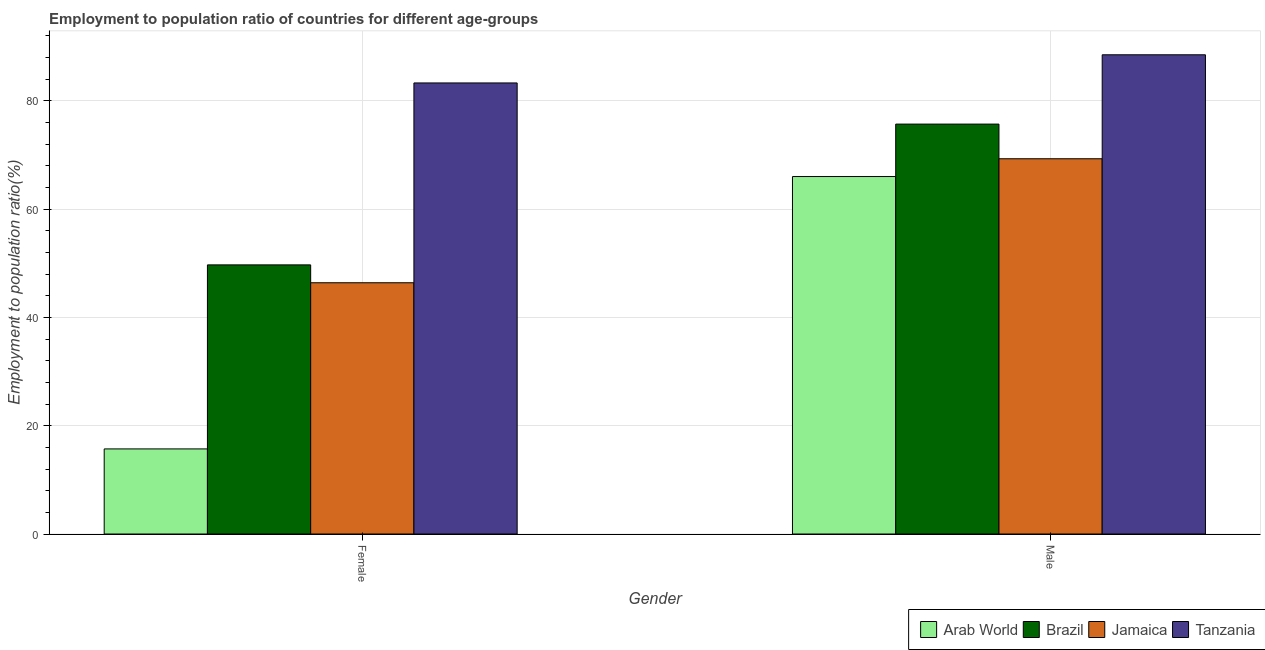How many different coloured bars are there?
Provide a short and direct response. 4. How many groups of bars are there?
Provide a short and direct response. 2. Are the number of bars on each tick of the X-axis equal?
Provide a succinct answer. Yes. What is the employment to population ratio(female) in Arab World?
Give a very brief answer. 15.71. Across all countries, what is the maximum employment to population ratio(female)?
Your answer should be compact. 83.3. Across all countries, what is the minimum employment to population ratio(female)?
Keep it short and to the point. 15.71. In which country was the employment to population ratio(male) maximum?
Your answer should be very brief. Tanzania. In which country was the employment to population ratio(female) minimum?
Your answer should be very brief. Arab World. What is the total employment to population ratio(male) in the graph?
Keep it short and to the point. 299.52. What is the difference between the employment to population ratio(female) in Tanzania and that in Jamaica?
Offer a terse response. 36.9. What is the difference between the employment to population ratio(male) in Arab World and the employment to population ratio(female) in Brazil?
Provide a succinct answer. 16.32. What is the average employment to population ratio(male) per country?
Give a very brief answer. 74.88. What is the difference between the employment to population ratio(female) and employment to population ratio(male) in Arab World?
Provide a short and direct response. -50.3. What is the ratio of the employment to population ratio(female) in Arab World to that in Brazil?
Ensure brevity in your answer.  0.32. In how many countries, is the employment to population ratio(female) greater than the average employment to population ratio(female) taken over all countries?
Make the answer very short. 2. What does the 2nd bar from the left in Male represents?
Ensure brevity in your answer.  Brazil. What does the 1st bar from the right in Female represents?
Provide a short and direct response. Tanzania. Are all the bars in the graph horizontal?
Provide a short and direct response. No. Are the values on the major ticks of Y-axis written in scientific E-notation?
Keep it short and to the point. No. Where does the legend appear in the graph?
Provide a short and direct response. Bottom right. How many legend labels are there?
Give a very brief answer. 4. How are the legend labels stacked?
Ensure brevity in your answer.  Horizontal. What is the title of the graph?
Ensure brevity in your answer.  Employment to population ratio of countries for different age-groups. Does "Macedonia" appear as one of the legend labels in the graph?
Make the answer very short. No. What is the label or title of the Y-axis?
Keep it short and to the point. Employment to population ratio(%). What is the Employment to population ratio(%) in Arab World in Female?
Your response must be concise. 15.71. What is the Employment to population ratio(%) in Brazil in Female?
Give a very brief answer. 49.7. What is the Employment to population ratio(%) in Jamaica in Female?
Offer a very short reply. 46.4. What is the Employment to population ratio(%) in Tanzania in Female?
Provide a short and direct response. 83.3. What is the Employment to population ratio(%) in Arab World in Male?
Your response must be concise. 66.02. What is the Employment to population ratio(%) in Brazil in Male?
Offer a very short reply. 75.7. What is the Employment to population ratio(%) of Jamaica in Male?
Offer a very short reply. 69.3. What is the Employment to population ratio(%) in Tanzania in Male?
Offer a very short reply. 88.5. Across all Gender, what is the maximum Employment to population ratio(%) of Arab World?
Make the answer very short. 66.02. Across all Gender, what is the maximum Employment to population ratio(%) in Brazil?
Provide a short and direct response. 75.7. Across all Gender, what is the maximum Employment to population ratio(%) of Jamaica?
Keep it short and to the point. 69.3. Across all Gender, what is the maximum Employment to population ratio(%) in Tanzania?
Your response must be concise. 88.5. Across all Gender, what is the minimum Employment to population ratio(%) in Arab World?
Offer a terse response. 15.71. Across all Gender, what is the minimum Employment to population ratio(%) of Brazil?
Provide a short and direct response. 49.7. Across all Gender, what is the minimum Employment to population ratio(%) of Jamaica?
Your response must be concise. 46.4. Across all Gender, what is the minimum Employment to population ratio(%) in Tanzania?
Your answer should be compact. 83.3. What is the total Employment to population ratio(%) in Arab World in the graph?
Give a very brief answer. 81.73. What is the total Employment to population ratio(%) of Brazil in the graph?
Offer a very short reply. 125.4. What is the total Employment to population ratio(%) of Jamaica in the graph?
Provide a succinct answer. 115.7. What is the total Employment to population ratio(%) of Tanzania in the graph?
Offer a terse response. 171.8. What is the difference between the Employment to population ratio(%) of Arab World in Female and that in Male?
Keep it short and to the point. -50.3. What is the difference between the Employment to population ratio(%) in Jamaica in Female and that in Male?
Make the answer very short. -22.9. What is the difference between the Employment to population ratio(%) of Tanzania in Female and that in Male?
Give a very brief answer. -5.2. What is the difference between the Employment to population ratio(%) in Arab World in Female and the Employment to population ratio(%) in Brazil in Male?
Ensure brevity in your answer.  -59.99. What is the difference between the Employment to population ratio(%) in Arab World in Female and the Employment to population ratio(%) in Jamaica in Male?
Your answer should be very brief. -53.59. What is the difference between the Employment to population ratio(%) of Arab World in Female and the Employment to population ratio(%) of Tanzania in Male?
Provide a short and direct response. -72.79. What is the difference between the Employment to population ratio(%) of Brazil in Female and the Employment to population ratio(%) of Jamaica in Male?
Make the answer very short. -19.6. What is the difference between the Employment to population ratio(%) in Brazil in Female and the Employment to population ratio(%) in Tanzania in Male?
Give a very brief answer. -38.8. What is the difference between the Employment to population ratio(%) in Jamaica in Female and the Employment to population ratio(%) in Tanzania in Male?
Keep it short and to the point. -42.1. What is the average Employment to population ratio(%) of Arab World per Gender?
Keep it short and to the point. 40.86. What is the average Employment to population ratio(%) in Brazil per Gender?
Offer a terse response. 62.7. What is the average Employment to population ratio(%) in Jamaica per Gender?
Ensure brevity in your answer.  57.85. What is the average Employment to population ratio(%) of Tanzania per Gender?
Your response must be concise. 85.9. What is the difference between the Employment to population ratio(%) in Arab World and Employment to population ratio(%) in Brazil in Female?
Keep it short and to the point. -33.99. What is the difference between the Employment to population ratio(%) in Arab World and Employment to population ratio(%) in Jamaica in Female?
Offer a very short reply. -30.69. What is the difference between the Employment to population ratio(%) in Arab World and Employment to population ratio(%) in Tanzania in Female?
Keep it short and to the point. -67.59. What is the difference between the Employment to population ratio(%) of Brazil and Employment to population ratio(%) of Tanzania in Female?
Provide a succinct answer. -33.6. What is the difference between the Employment to population ratio(%) in Jamaica and Employment to population ratio(%) in Tanzania in Female?
Keep it short and to the point. -36.9. What is the difference between the Employment to population ratio(%) in Arab World and Employment to population ratio(%) in Brazil in Male?
Your response must be concise. -9.69. What is the difference between the Employment to population ratio(%) of Arab World and Employment to population ratio(%) of Jamaica in Male?
Offer a very short reply. -3.29. What is the difference between the Employment to population ratio(%) in Arab World and Employment to population ratio(%) in Tanzania in Male?
Give a very brief answer. -22.48. What is the difference between the Employment to population ratio(%) in Jamaica and Employment to population ratio(%) in Tanzania in Male?
Make the answer very short. -19.2. What is the ratio of the Employment to population ratio(%) of Arab World in Female to that in Male?
Provide a short and direct response. 0.24. What is the ratio of the Employment to population ratio(%) in Brazil in Female to that in Male?
Your answer should be very brief. 0.66. What is the ratio of the Employment to population ratio(%) in Jamaica in Female to that in Male?
Your response must be concise. 0.67. What is the ratio of the Employment to population ratio(%) in Tanzania in Female to that in Male?
Provide a short and direct response. 0.94. What is the difference between the highest and the second highest Employment to population ratio(%) of Arab World?
Give a very brief answer. 50.3. What is the difference between the highest and the second highest Employment to population ratio(%) of Brazil?
Offer a terse response. 26. What is the difference between the highest and the second highest Employment to population ratio(%) of Jamaica?
Provide a succinct answer. 22.9. What is the difference between the highest and the second highest Employment to population ratio(%) in Tanzania?
Offer a very short reply. 5.2. What is the difference between the highest and the lowest Employment to population ratio(%) in Arab World?
Provide a short and direct response. 50.3. What is the difference between the highest and the lowest Employment to population ratio(%) of Brazil?
Offer a terse response. 26. What is the difference between the highest and the lowest Employment to population ratio(%) of Jamaica?
Ensure brevity in your answer.  22.9. What is the difference between the highest and the lowest Employment to population ratio(%) in Tanzania?
Give a very brief answer. 5.2. 